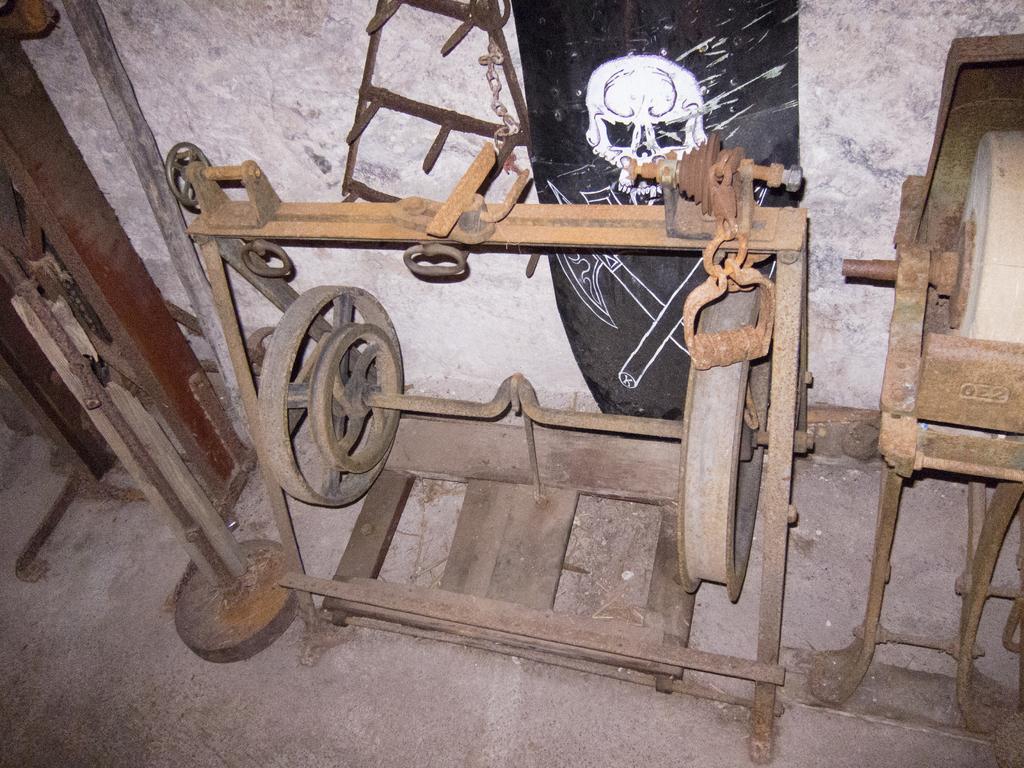In one or two sentences, can you explain what this image depicts? In this image I can see the ground and few metal objects on the ground which are brown and black in color. In the background I can see the white colored wall, a board which is black in color and on the board I can see a white colored painting of the skull. 